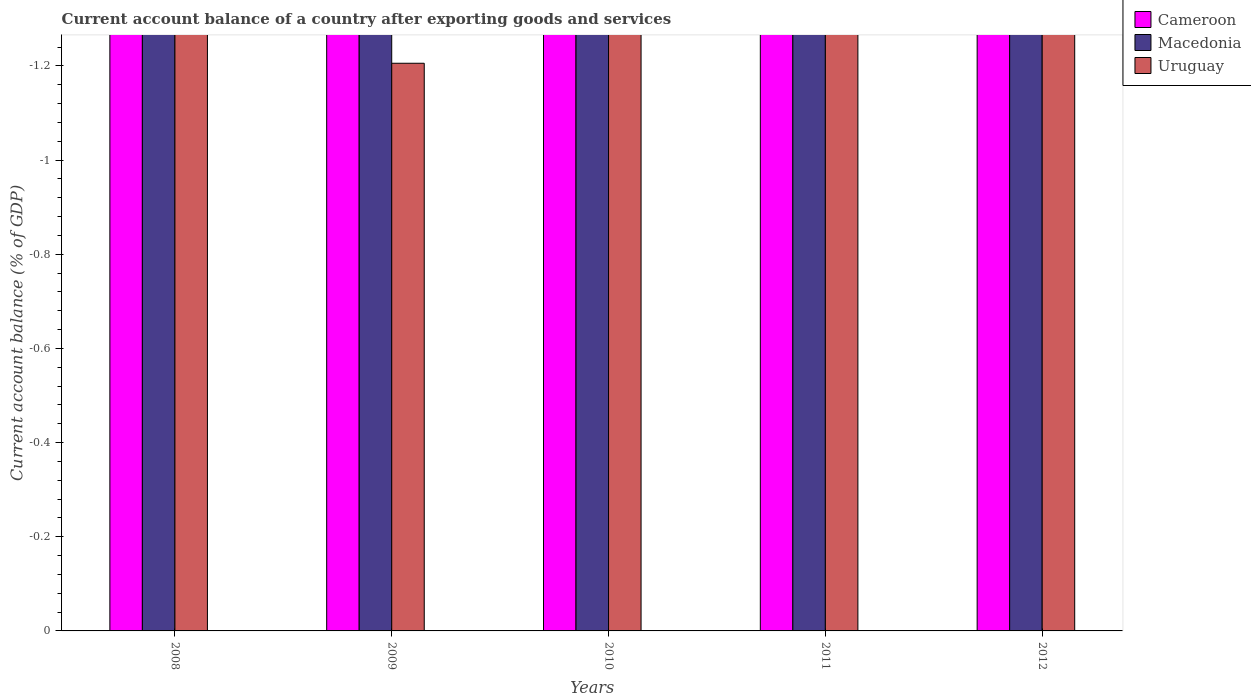How many different coloured bars are there?
Make the answer very short. 0. Are the number of bars per tick equal to the number of legend labels?
Your response must be concise. No. How many bars are there on the 4th tick from the right?
Your answer should be very brief. 0. What is the label of the 3rd group of bars from the left?
Make the answer very short. 2010. In how many cases, is the number of bars for a given year not equal to the number of legend labels?
Your answer should be compact. 5. Across all years, what is the minimum account balance in Uruguay?
Your answer should be very brief. 0. What is the difference between the account balance in Uruguay in 2010 and the account balance in Cameroon in 2009?
Give a very brief answer. 0. Is it the case that in every year, the sum of the account balance in Uruguay and account balance in Cameroon is greater than the account balance in Macedonia?
Ensure brevity in your answer.  No. Are all the bars in the graph horizontal?
Provide a short and direct response. No. How many years are there in the graph?
Give a very brief answer. 5. What is the difference between two consecutive major ticks on the Y-axis?
Offer a very short reply. 0.2. Does the graph contain grids?
Provide a succinct answer. No. How many legend labels are there?
Your answer should be very brief. 3. What is the title of the graph?
Provide a short and direct response. Current account balance of a country after exporting goods and services. Does "Malaysia" appear as one of the legend labels in the graph?
Offer a very short reply. No. What is the label or title of the Y-axis?
Your answer should be compact. Current account balance (% of GDP). What is the Current account balance (% of GDP) of Uruguay in 2008?
Offer a very short reply. 0. What is the Current account balance (% of GDP) in Cameroon in 2009?
Your answer should be very brief. 0. What is the Current account balance (% of GDP) in Uruguay in 2009?
Offer a terse response. 0. What is the Current account balance (% of GDP) in Macedonia in 2010?
Your answer should be compact. 0. What is the Current account balance (% of GDP) of Uruguay in 2010?
Your answer should be very brief. 0. What is the Current account balance (% of GDP) in Macedonia in 2011?
Ensure brevity in your answer.  0. What is the Current account balance (% of GDP) in Macedonia in 2012?
Offer a terse response. 0. What is the Current account balance (% of GDP) in Uruguay in 2012?
Your response must be concise. 0. What is the total Current account balance (% of GDP) of Cameroon in the graph?
Provide a succinct answer. 0. What is the total Current account balance (% of GDP) in Macedonia in the graph?
Give a very brief answer. 0. What is the total Current account balance (% of GDP) in Uruguay in the graph?
Offer a very short reply. 0. What is the average Current account balance (% of GDP) of Cameroon per year?
Provide a succinct answer. 0. 